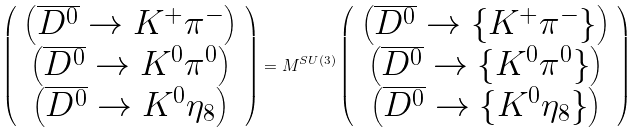Convert formula to latex. <formula><loc_0><loc_0><loc_500><loc_500>\left ( \begin{array} { c } { { \left ( \overline { { { D ^ { 0 } } } } \rightarrow K ^ { + } \pi ^ { - } \right ) } } \\ { { \left ( \overline { { { D ^ { 0 } } } } \rightarrow K ^ { 0 } \pi ^ { 0 } \right ) } } \\ { { \left ( \overline { { { D ^ { 0 } } } } \rightarrow K ^ { 0 } \eta _ { 8 } \right ) } } \end{array} \right ) = M ^ { S U ( 3 ) } \left ( \begin{array} { c } { { \left ( \overline { { { D ^ { 0 } } } } \rightarrow \left \{ K ^ { + } \pi ^ { - } \right \} \right ) } } \\ { { \left ( \overline { { { D ^ { 0 } } } } \rightarrow \left \{ K ^ { 0 } \pi ^ { 0 } \right \} \right ) } } \\ { { \left ( \overline { { { D ^ { 0 } } } } \rightarrow \left \{ K ^ { 0 } \eta _ { 8 } \right \} \right ) } } \end{array} \right )</formula> 